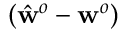Convert formula to latex. <formula><loc_0><loc_0><loc_500><loc_500>( \hat { w } ^ { o } - w ^ { o } )</formula> 